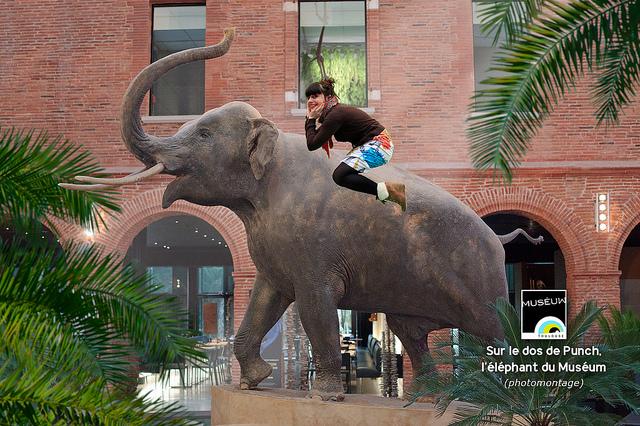What type of elephant is this?
Concise answer only. African. What is on the elephants back?
Concise answer only. Woman. Is this an edited photo?
Keep it brief. Yes. Is the visible text English?
Concise answer only. No. 